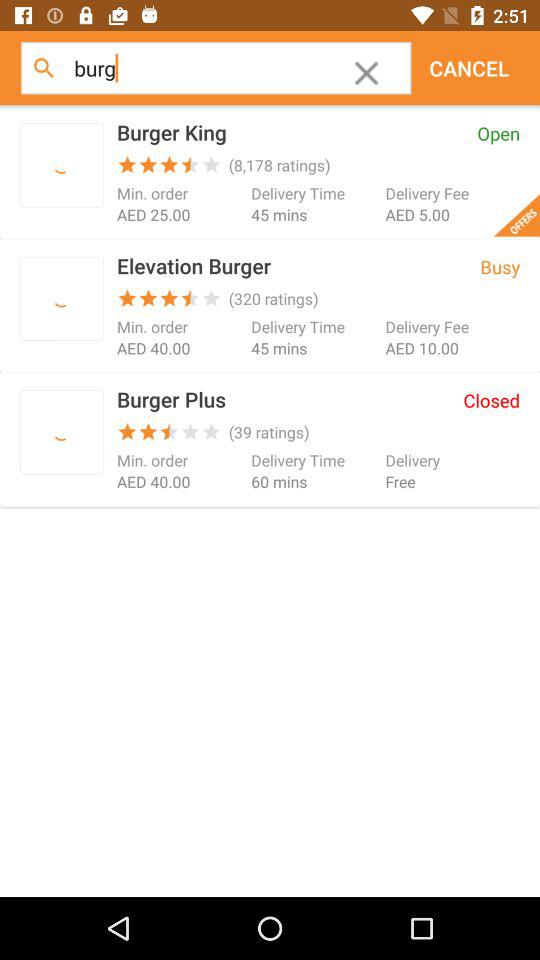Is "Burger Plus" open or closed? "Burger Plus" is closed. 